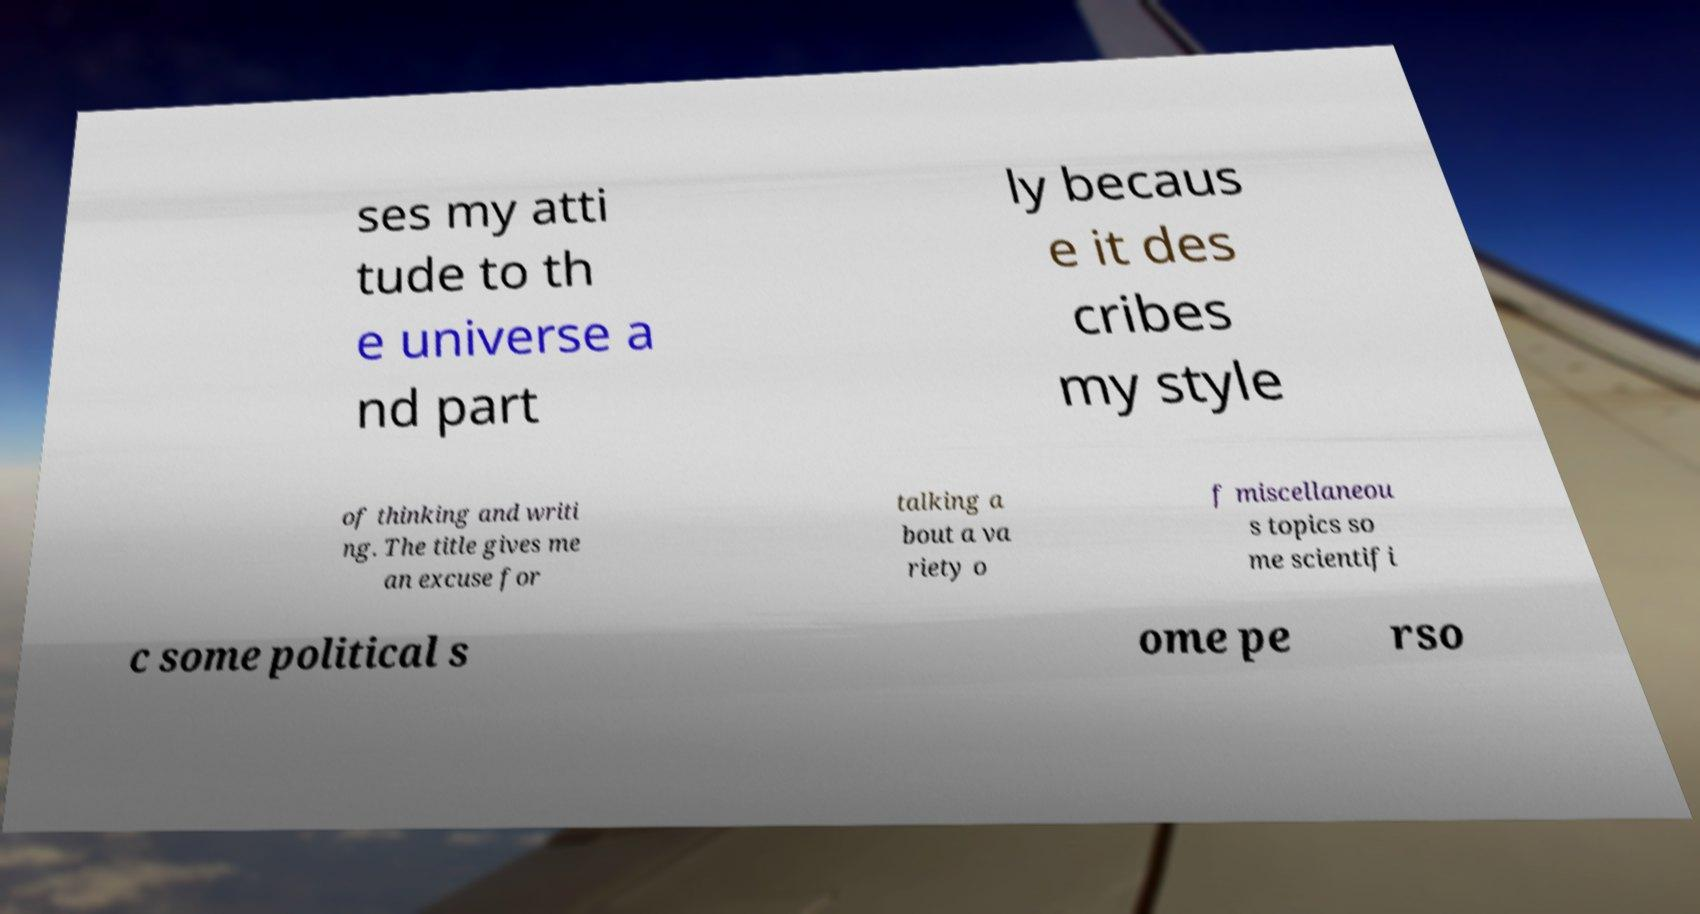I need the written content from this picture converted into text. Can you do that? ses my atti tude to th e universe a nd part ly becaus e it des cribes my style of thinking and writi ng. The title gives me an excuse for talking a bout a va riety o f miscellaneou s topics so me scientifi c some political s ome pe rso 